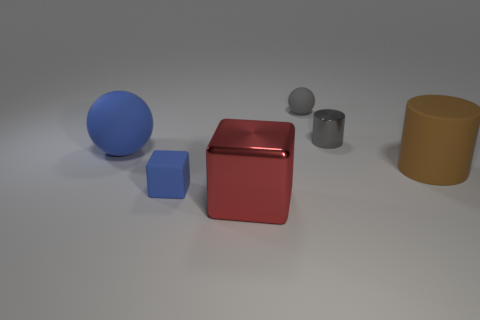Are there any other things that are the same material as the small blue object?
Provide a succinct answer. Yes. There is a large blue object; is its shape the same as the tiny rubber object behind the large brown rubber thing?
Your answer should be very brief. Yes. Is the number of big things left of the gray sphere greater than the number of tiny blue things in front of the large metallic cube?
Provide a succinct answer. Yes. Is there anything else that has the same color as the tiny metal thing?
Your answer should be very brief. Yes. Is there a brown matte cylinder that is in front of the small object that is behind the metallic object behind the red shiny object?
Your response must be concise. Yes. There is a matte object on the right side of the small sphere; does it have the same shape as the small shiny thing?
Your response must be concise. Yes. Are there fewer big blue matte spheres behind the large sphere than things that are left of the gray metal thing?
Make the answer very short. Yes. What is the material of the small cylinder?
Offer a very short reply. Metal. Is the color of the large rubber ball the same as the rubber thing in front of the big rubber cylinder?
Make the answer very short. Yes. How many brown matte cylinders are to the right of the matte cube?
Make the answer very short. 1. 